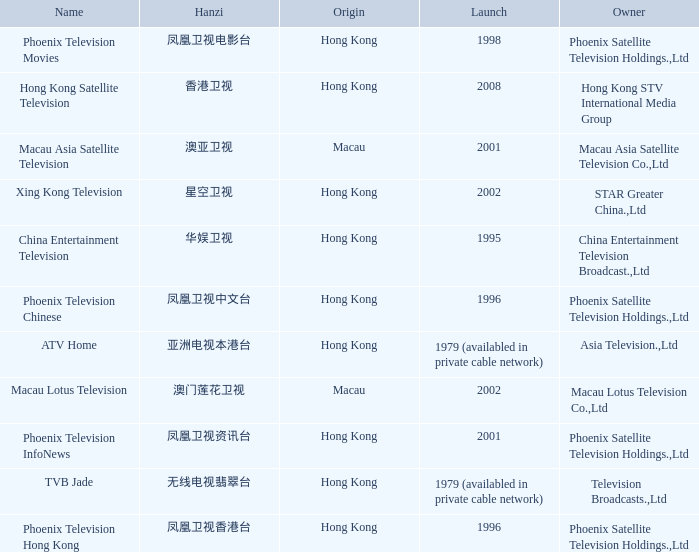Can you parse all the data within this table? {'header': ['Name', 'Hanzi', 'Origin', 'Launch', 'Owner'], 'rows': [['Phoenix Television Movies', '凤凰卫视电影台', 'Hong Kong', '1998', 'Phoenix Satellite Television Holdings.,Ltd'], ['Hong Kong Satellite Television', '香港卫视', 'Hong Kong', '2008', 'Hong Kong STV International Media Group'], ['Macau Asia Satellite Television', '澳亚卫视', 'Macau', '2001', 'Macau Asia Satellite Television Co.,Ltd'], ['Xing Kong Television', '星空卫视', 'Hong Kong', '2002', 'STAR Greater China.,Ltd'], ['China Entertainment Television', '华娱卫视', 'Hong Kong', '1995', 'China Entertainment Television Broadcast.,Ltd'], ['Phoenix Television Chinese', '凤凰卫视中文台', 'Hong Kong', '1996', 'Phoenix Satellite Television Holdings.,Ltd'], ['ATV Home', '亚洲电视本港台', 'Hong Kong', '1979 (availabled in private cable network)', 'Asia Television.,Ltd'], ['Macau Lotus Television', '澳门莲花卫视', 'Macau', '2002', 'Macau Lotus Television Co.,Ltd'], ['Phoenix Television InfoNews', '凤凰卫视资讯台', 'Hong Kong', '2001', 'Phoenix Satellite Television Holdings.,Ltd'], ['TVB Jade', '无线电视翡翠台', 'Hong Kong', '1979 (availabled in private cable network)', 'Television Broadcasts.,Ltd'], ['Phoenix Television Hong Kong', '凤凰卫视香港台', 'Hong Kong', '1996', 'Phoenix Satellite Television Holdings.,Ltd']]} Which company launched in 1996 and has a Hanzi of 凤凰卫视中文台? Phoenix Television Chinese. 